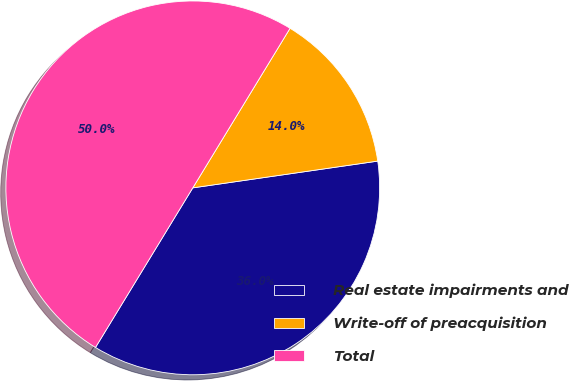Convert chart. <chart><loc_0><loc_0><loc_500><loc_500><pie_chart><fcel>Real estate impairments and<fcel>Write-off of preacquisition<fcel>Total<nl><fcel>36.0%<fcel>14.0%<fcel>50.0%<nl></chart> 